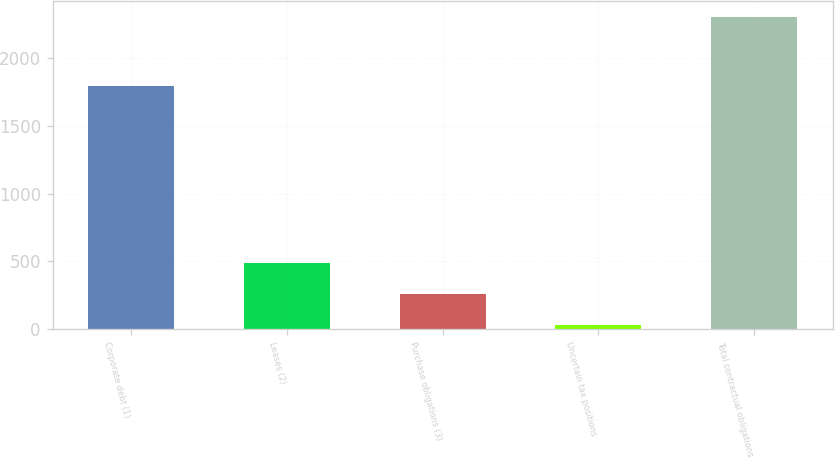<chart> <loc_0><loc_0><loc_500><loc_500><bar_chart><fcel>Corporate debt (1)<fcel>Leases (2)<fcel>Purchase obligations (3)<fcel>Uncertain tax positions<fcel>Total contractual obligations<nl><fcel>1795<fcel>485.6<fcel>258.3<fcel>31<fcel>2304<nl></chart> 